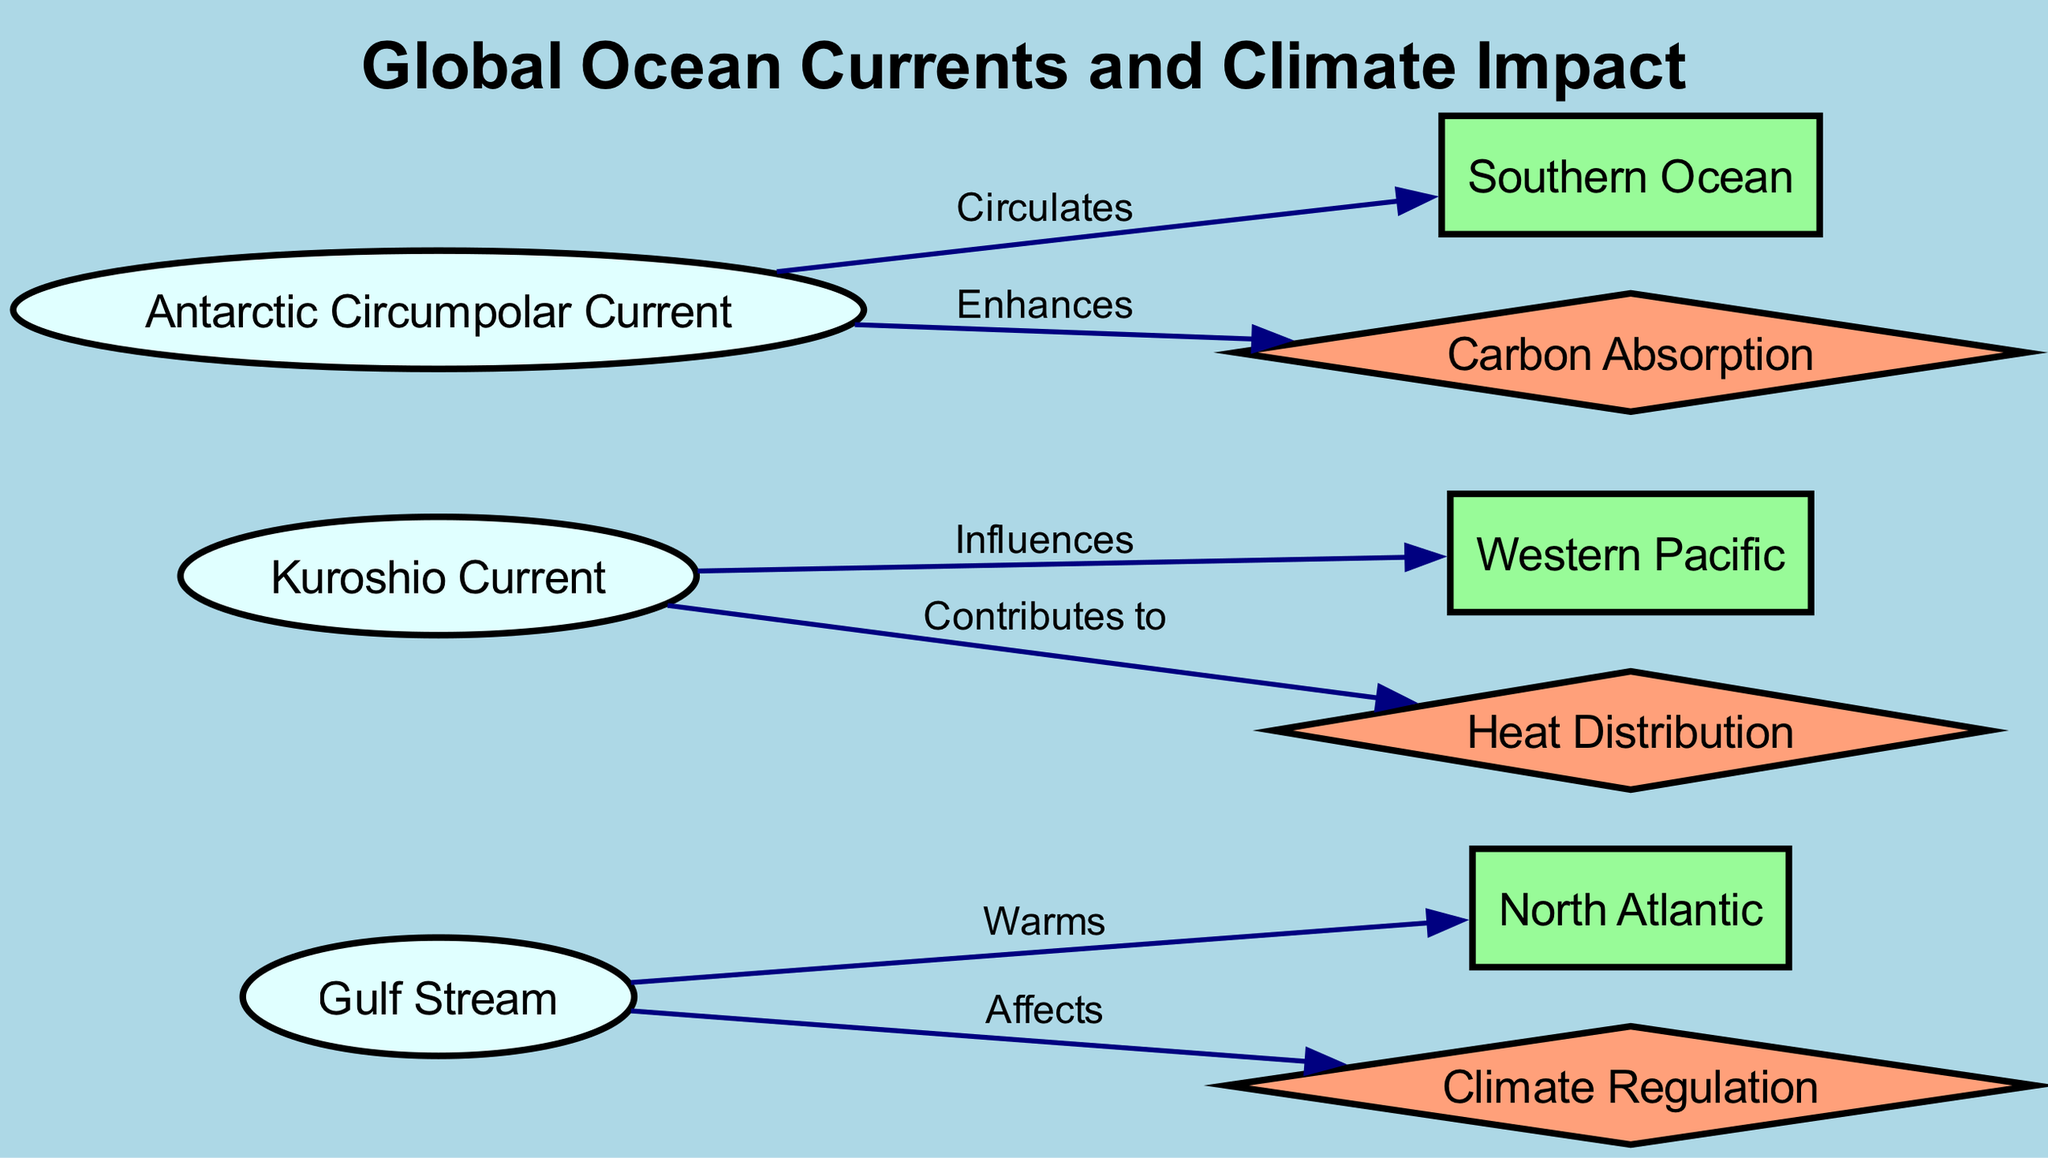What is the total number of ocean currents represented in the diagram? The diagram features three ocean currents: Gulf Stream, Kuroshio Current, and Antarctic Circumpolar Current. By counting these entries, one can ascertain that the total amount of ocean currents in the diagram is three.
Answer: 3 Which region does the Gulf Stream warm? According to the diagram, the Gulf Stream is connected to the North Atlantic region by an edge labeled "Warms". This shows the direct relationship and indicates that the Gulf Stream's warm water affects the North Atlantic.
Answer: North Atlantic What impact does the Kuroshio Current contribute to? In the diagram, there is an edge connecting the Kuroshio Current to the impact labeled "Heat Distribution". This indicates that the Kuroshio Current plays a role in this climate impact area.
Answer: Heat Distribution How many effects of ocean currents are listed in the diagram? The diagram lists three effects: Climate Regulation, Heat Distribution, and Carbon Absorption. By counting these specific impacts, we find that there are three distinct effects presented.
Answer: 3 Which ocean current enhances carbon absorption? The diagram indicates that the Antarctic Circumpolar Current enhances Carbon Absorption, as represented by the edge labeled "Enhances" connecting the Antarctic Circumpolar Current to the carbon absorption impact.
Answer: Antarctic Circumpolar Current What is the primary effect associated with the Gulf Stream? In the diagram, the Gulf Stream has an edge labeled "Affects" connecting it to Climate Regulation. This relationship demonstrates that the Gulf Stream has a primary effect on climate regulation.
Answer: Climate Regulation Which ocean current influences the Western Pacific region? The Kuroshio Current is connected to the Western Pacific region via an edge labeled "Influences". Therefore, it is the Kuroshio Current that influences this particular region.
Answer: Kuroshio Current 